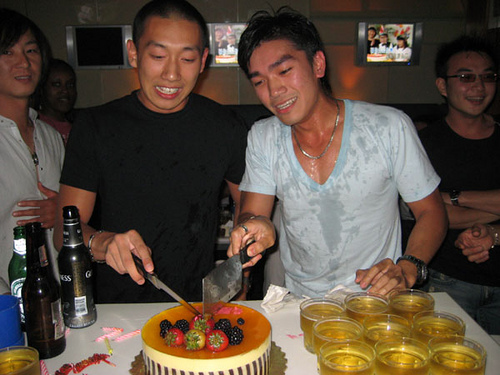Is that a birthday cake? Yes, considering the decorations and the festive setting, it is likely a birthday cake. 